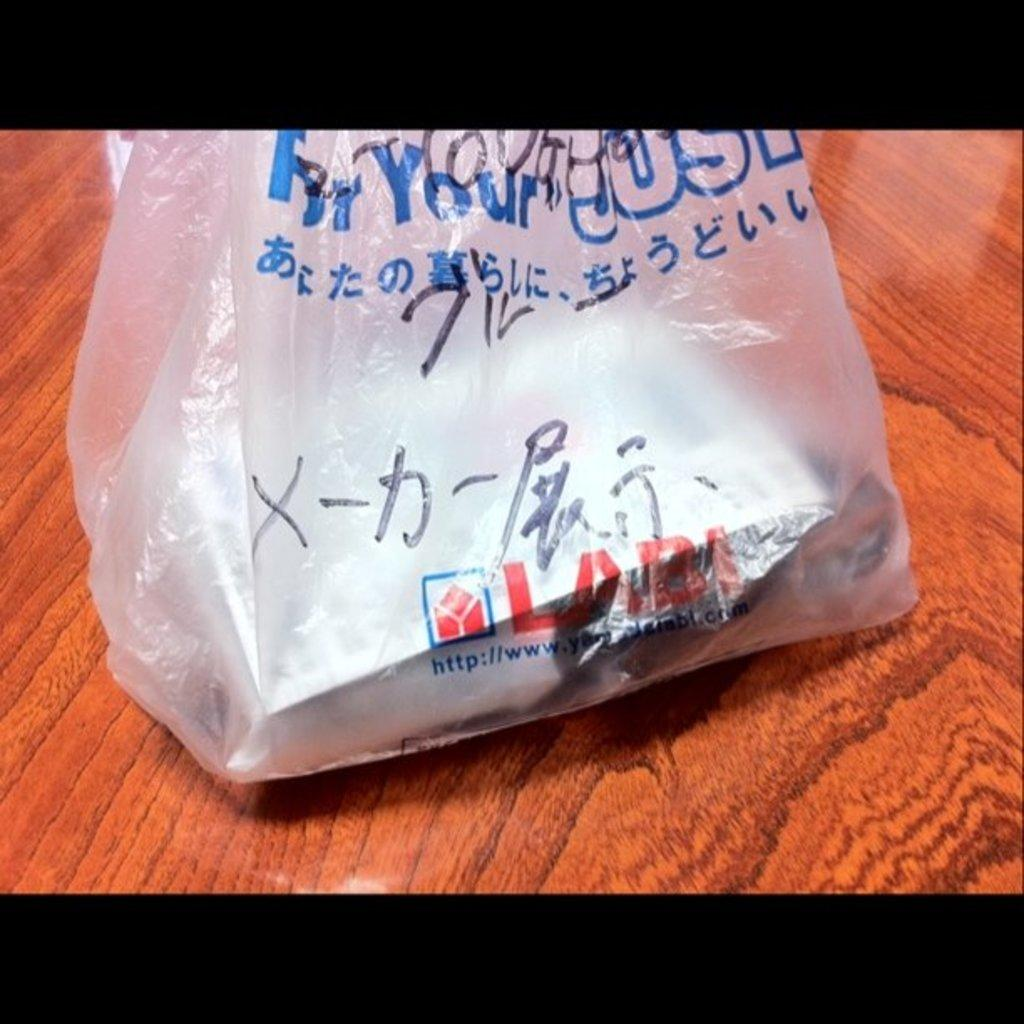What color is the table in the image? The table in the image is brown-colored. What is covering the table? There is a plastic cover on the table. What can be found underneath the plastic cover? There are objects inside the plastic cover. Is there any text or design on the plastic cover? Yes, there is writing on the plastic cover. How many cakes are being rung by the bells in the image? There are no cakes or bells present in the image. 